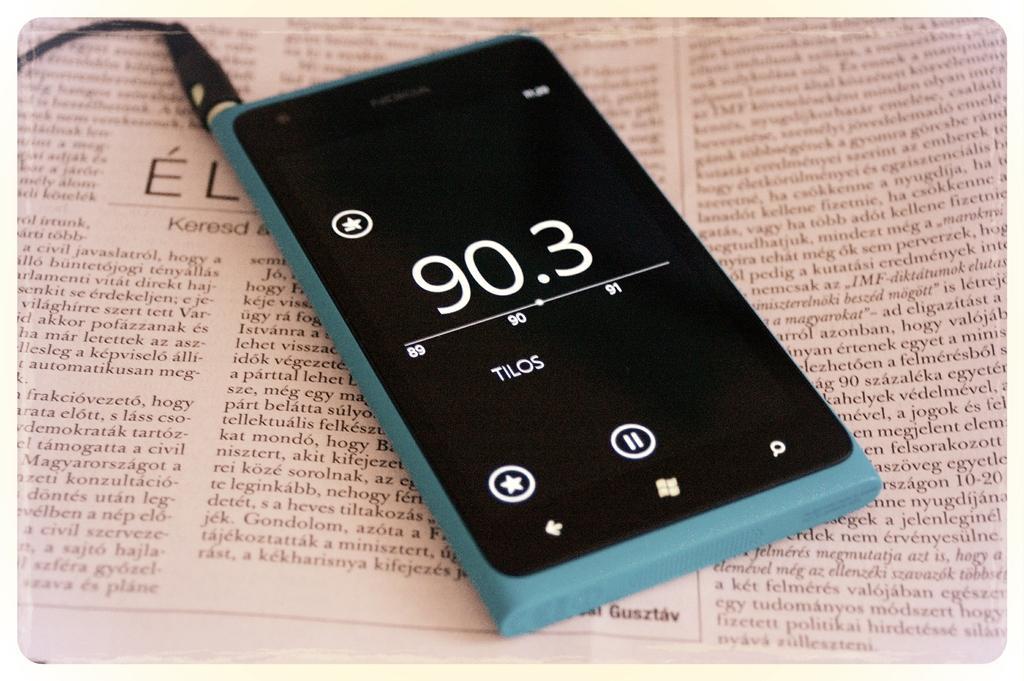Describe this image in one or two sentences. This image consists of a mobile phone. To which a wire is connected. At the bottom, there is a newspaper. 